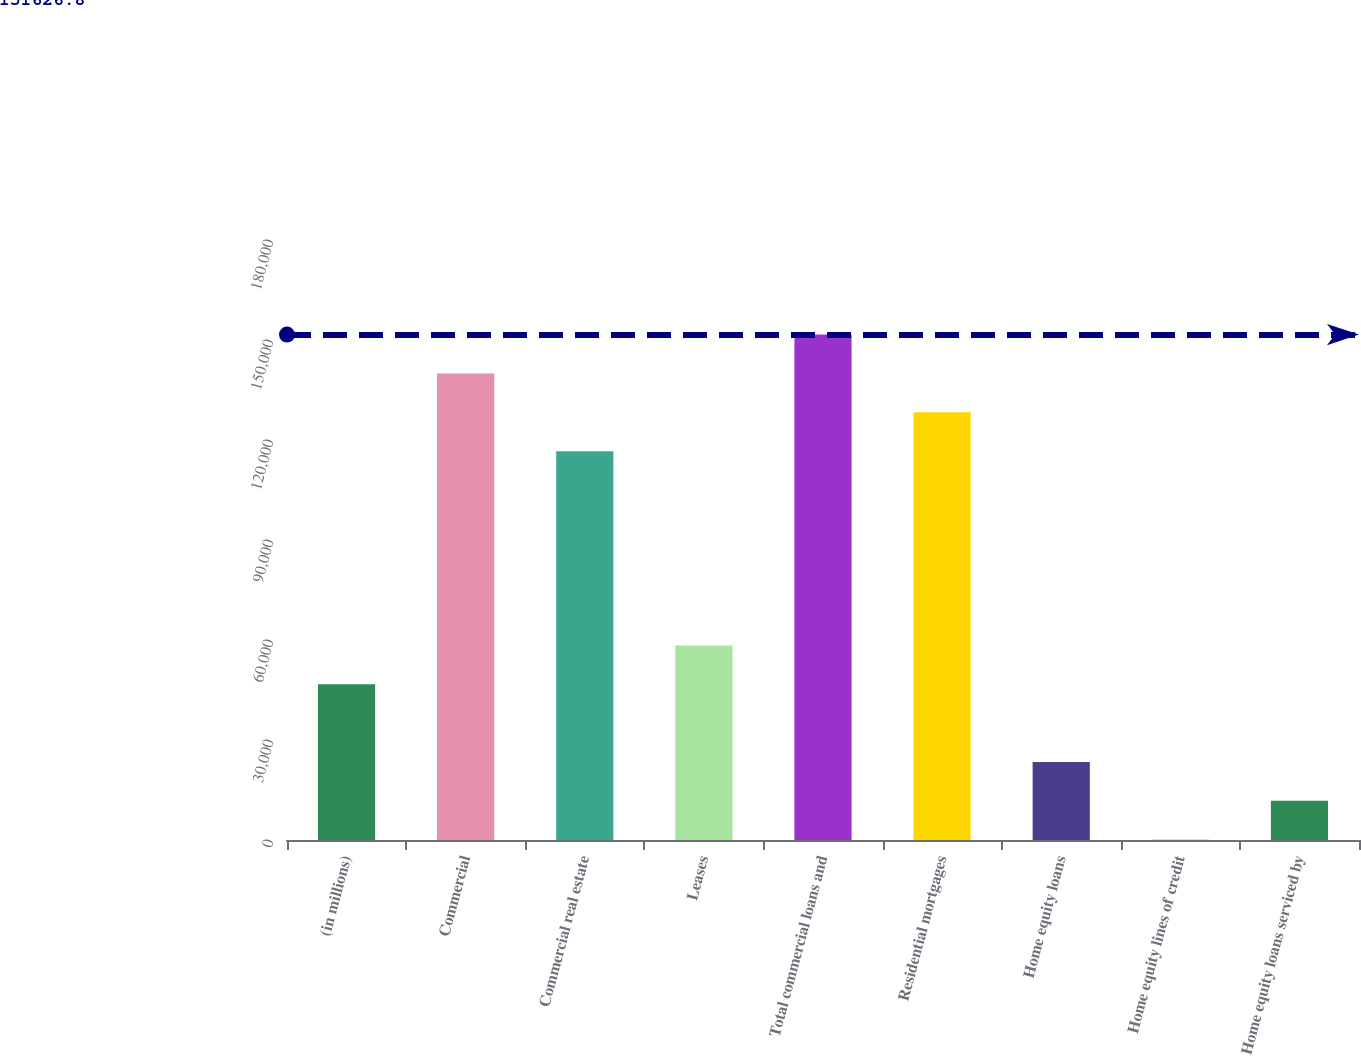Convert chart. <chart><loc_0><loc_0><loc_500><loc_500><bar_chart><fcel>(in millions)<fcel>Commercial<fcel>Commercial real estate<fcel>Leases<fcel>Total commercial loans and<fcel>Residential mortgages<fcel>Home equity loans<fcel>Home equity lines of credit<fcel>Home equity loans serviced by<nl><fcel>46726.4<fcel>139971<fcel>116660<fcel>58382<fcel>151627<fcel>128316<fcel>23415.2<fcel>104<fcel>11759.6<nl></chart> 